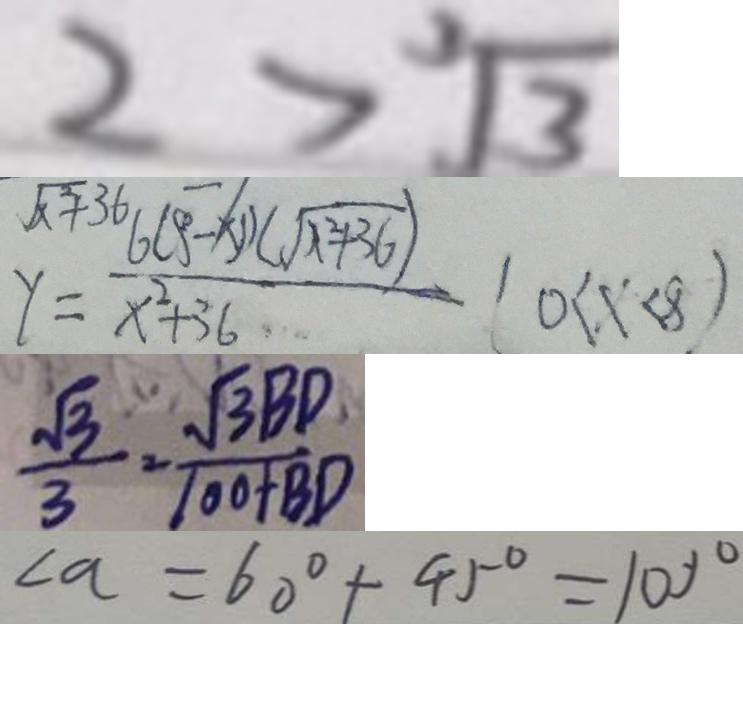<formula> <loc_0><loc_0><loc_500><loc_500>2 > \sqrt [ 3 ] { 3 } 
 y = \frac { 6 ( 8 - x ) ( \sqrt { x ^ { 2 } + 3 6 } ) } { x ^ { 2 } + 3 6 } ( 0 < x < 8 ) 
 \frac { \sqrt { 3 } } { 3 } = \frac { \sqrt { 3 } B D } { 1 0 0 + B D } 
 \angle a = 6 0 ^ { \circ } + 4 5 ^ { \circ } = 1 0 0 ^ { \circ }</formula> 